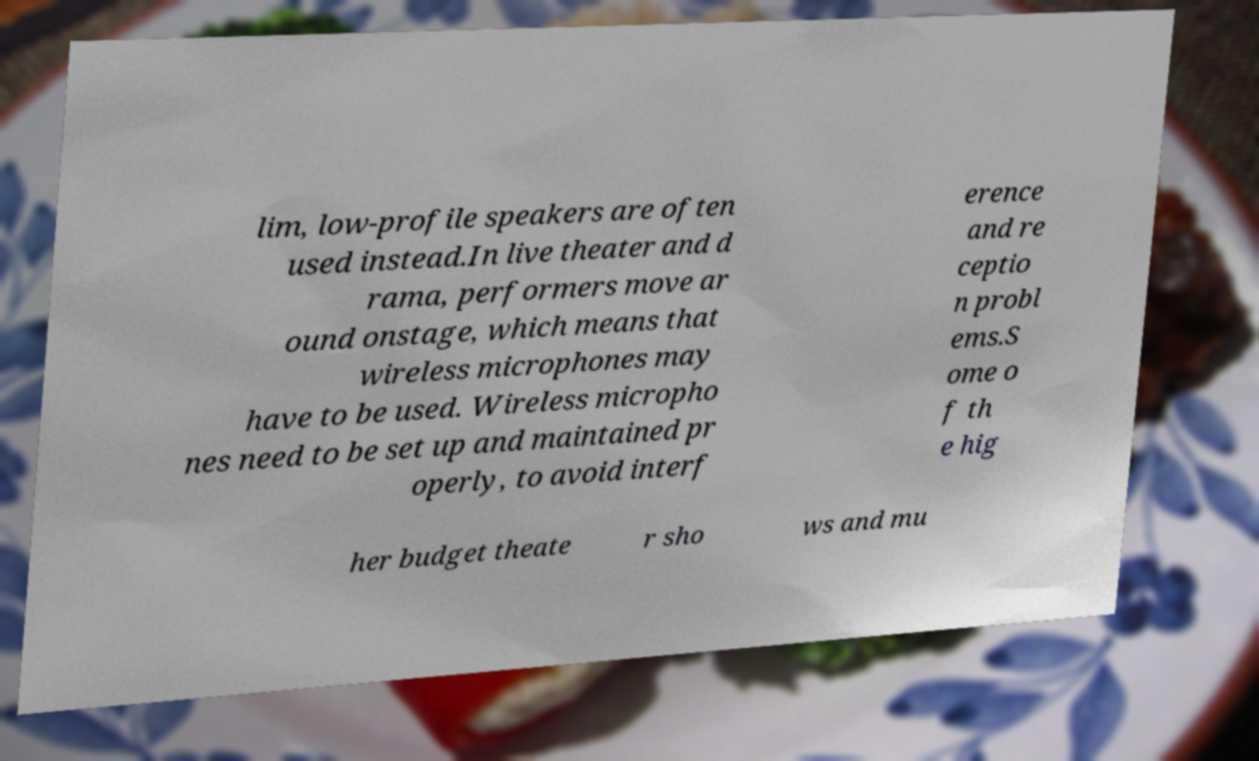Could you extract and type out the text from this image? lim, low-profile speakers are often used instead.In live theater and d rama, performers move ar ound onstage, which means that wireless microphones may have to be used. Wireless micropho nes need to be set up and maintained pr operly, to avoid interf erence and re ceptio n probl ems.S ome o f th e hig her budget theate r sho ws and mu 